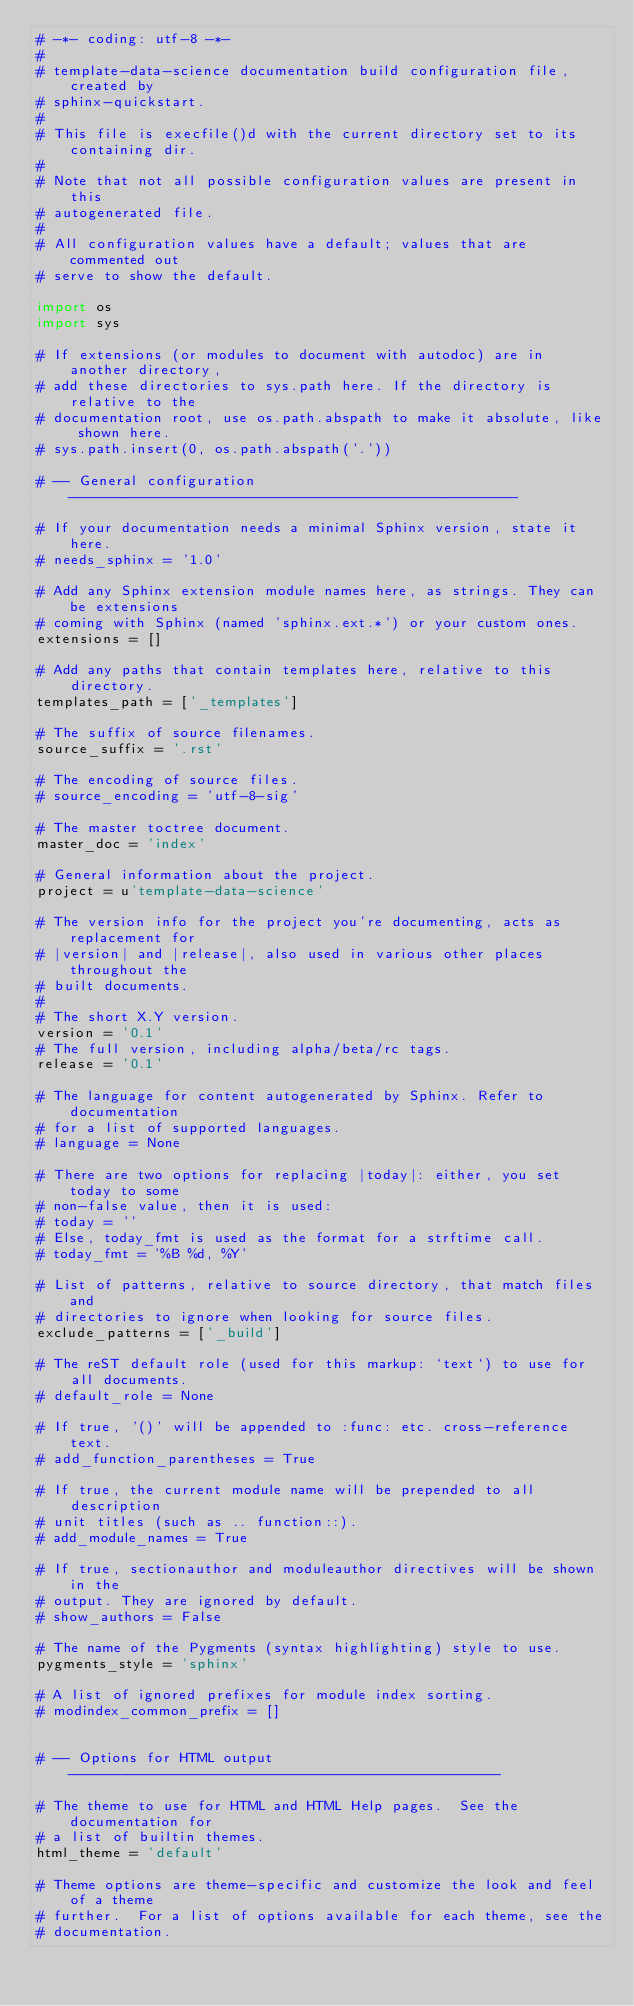<code> <loc_0><loc_0><loc_500><loc_500><_Python_># -*- coding: utf-8 -*-
#
# template-data-science documentation build configuration file, created by
# sphinx-quickstart.
#
# This file is execfile()d with the current directory set to its containing dir.
#
# Note that not all possible configuration values are present in this
# autogenerated file.
#
# All configuration values have a default; values that are commented out
# serve to show the default.

import os
import sys

# If extensions (or modules to document with autodoc) are in another directory,
# add these directories to sys.path here. If the directory is relative to the
# documentation root, use os.path.abspath to make it absolute, like shown here.
# sys.path.insert(0, os.path.abspath('.'))

# -- General configuration -----------------------------------------------------

# If your documentation needs a minimal Sphinx version, state it here.
# needs_sphinx = '1.0'

# Add any Sphinx extension module names here, as strings. They can be extensions
# coming with Sphinx (named 'sphinx.ext.*') or your custom ones.
extensions = []

# Add any paths that contain templates here, relative to this directory.
templates_path = ['_templates']

# The suffix of source filenames.
source_suffix = '.rst'

# The encoding of source files.
# source_encoding = 'utf-8-sig'

# The master toctree document.
master_doc = 'index'

# General information about the project.
project = u'template-data-science'

# The version info for the project you're documenting, acts as replacement for
# |version| and |release|, also used in various other places throughout the
# built documents.
#
# The short X.Y version.
version = '0.1'
# The full version, including alpha/beta/rc tags.
release = '0.1'

# The language for content autogenerated by Sphinx. Refer to documentation
# for a list of supported languages.
# language = None

# There are two options for replacing |today|: either, you set today to some
# non-false value, then it is used:
# today = ''
# Else, today_fmt is used as the format for a strftime call.
# today_fmt = '%B %d, %Y'

# List of patterns, relative to source directory, that match files and
# directories to ignore when looking for source files.
exclude_patterns = ['_build']

# The reST default role (used for this markup: `text`) to use for all documents.
# default_role = None

# If true, '()' will be appended to :func: etc. cross-reference text.
# add_function_parentheses = True

# If true, the current module name will be prepended to all description
# unit titles (such as .. function::).
# add_module_names = True

# If true, sectionauthor and moduleauthor directives will be shown in the
# output. They are ignored by default.
# show_authors = False

# The name of the Pygments (syntax highlighting) style to use.
pygments_style = 'sphinx'

# A list of ignored prefixes for module index sorting.
# modindex_common_prefix = []


# -- Options for HTML output ---------------------------------------------------

# The theme to use for HTML and HTML Help pages.  See the documentation for
# a list of builtin themes.
html_theme = 'default'

# Theme options are theme-specific and customize the look and feel of a theme
# further.  For a list of options available for each theme, see the
# documentation.</code> 